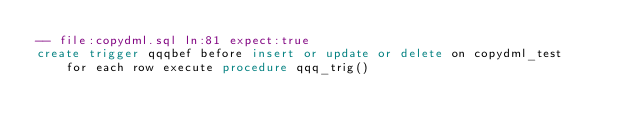Convert code to text. <code><loc_0><loc_0><loc_500><loc_500><_SQL_>-- file:copydml.sql ln:81 expect:true
create trigger qqqbef before insert or update or delete on copydml_test
    for each row execute procedure qqq_trig()
</code> 